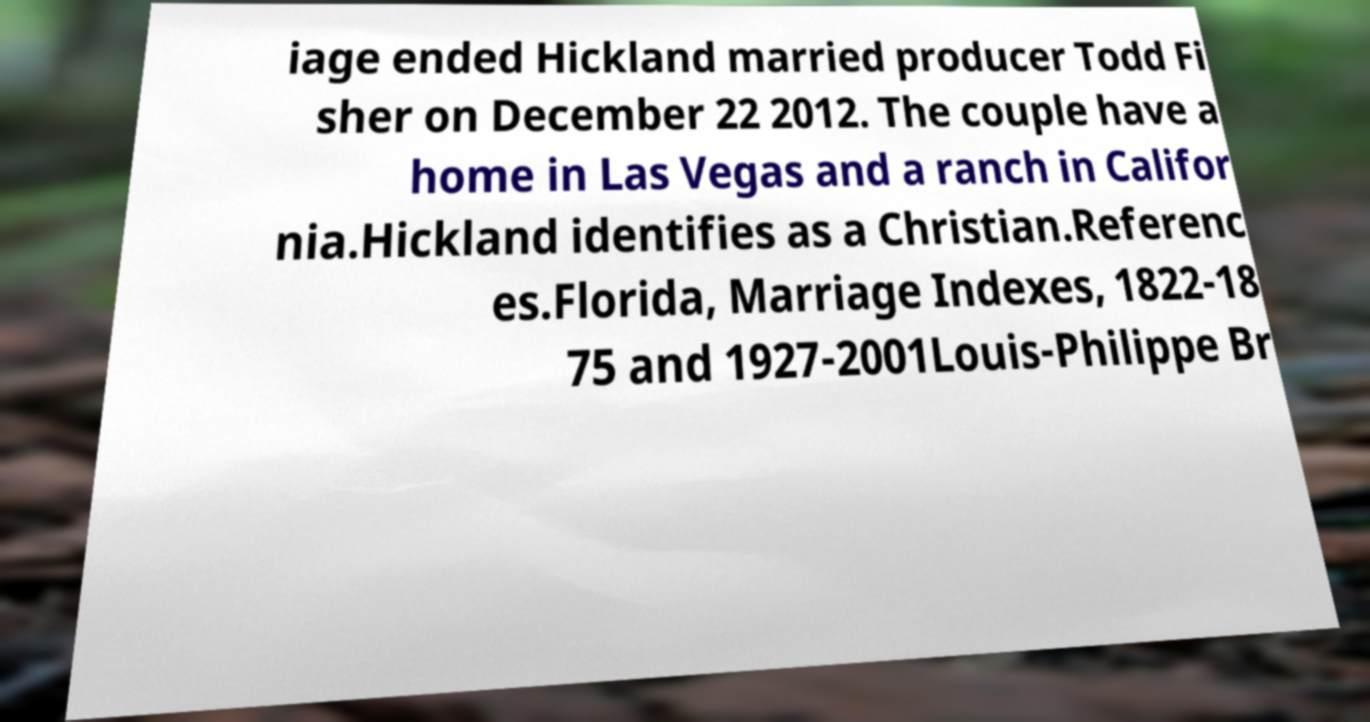What messages or text are displayed in this image? I need them in a readable, typed format. iage ended Hickland married producer Todd Fi sher on December 22 2012. The couple have a home in Las Vegas and a ranch in Califor nia.Hickland identifies as a Christian.Referenc es.Florida, Marriage Indexes, 1822-18 75 and 1927-2001Louis-Philippe Br 